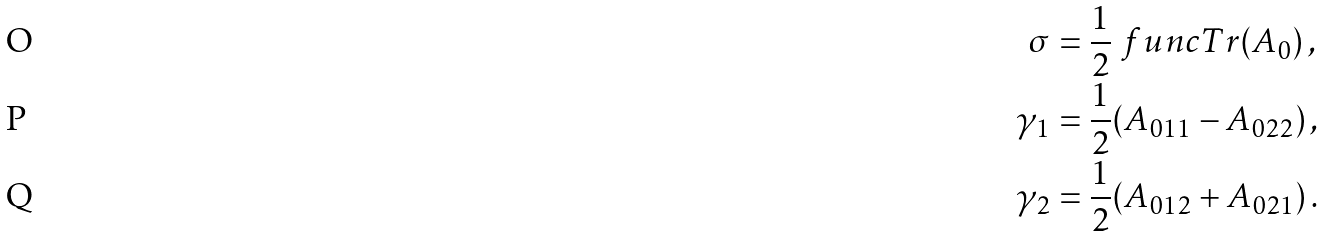Convert formula to latex. <formula><loc_0><loc_0><loc_500><loc_500>\sigma & = \frac { 1 } { 2 } \ f u n c { T r } ( A _ { 0 } ) \, , \\ \gamma _ { 1 } & = \frac { 1 } { 2 } ( A _ { 0 1 1 } - A _ { 0 2 2 } ) \, , \\ \gamma _ { 2 } & = \frac { 1 } { 2 } ( A _ { 0 1 2 } + A _ { 0 2 1 } ) \, .</formula> 